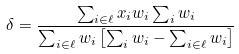Convert formula to latex. <formula><loc_0><loc_0><loc_500><loc_500>\delta = \frac { \sum _ { i \in \ell } x _ { i } w _ { i } \sum _ { i } w _ { i } } { \sum _ { i \in \ell } w _ { i } \left [ \sum _ { i } w _ { i } - \sum _ { i \in \ell } w _ { i } \right ] }</formula> 